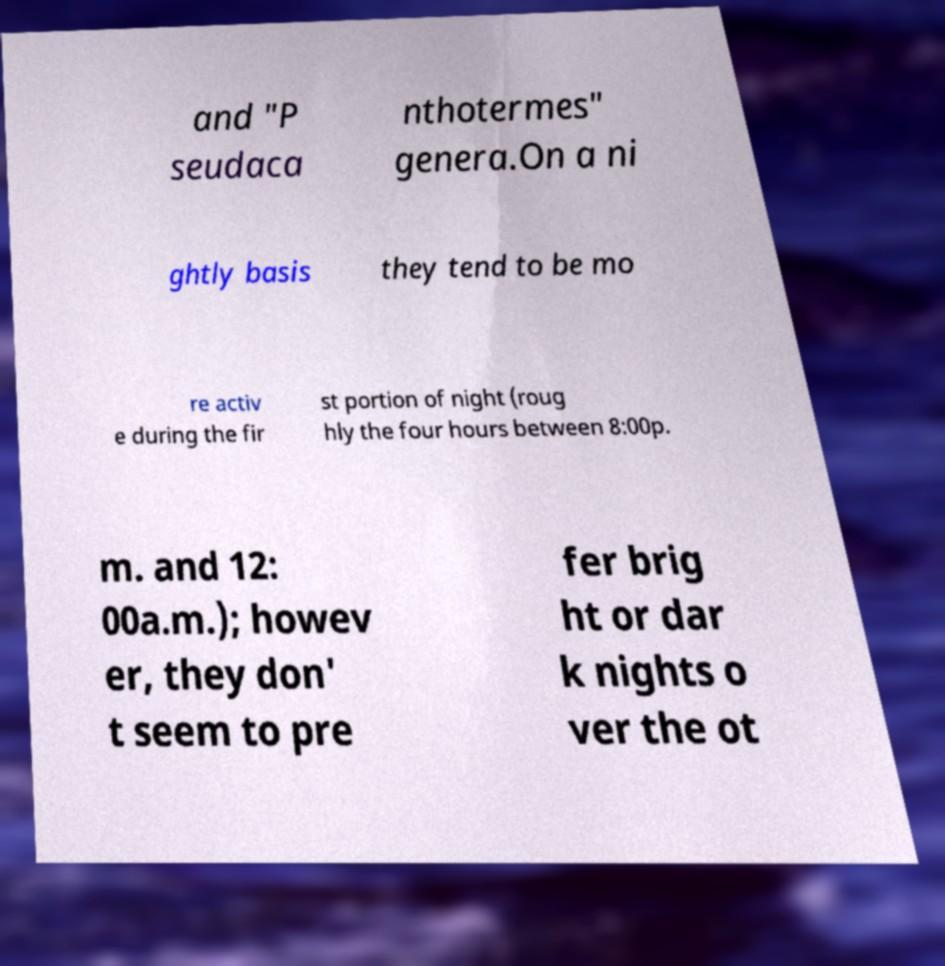Could you assist in decoding the text presented in this image and type it out clearly? and "P seudaca nthotermes" genera.On a ni ghtly basis they tend to be mo re activ e during the fir st portion of night (roug hly the four hours between 8:00p. m. and 12: 00a.m.); howev er, they don' t seem to pre fer brig ht or dar k nights o ver the ot 